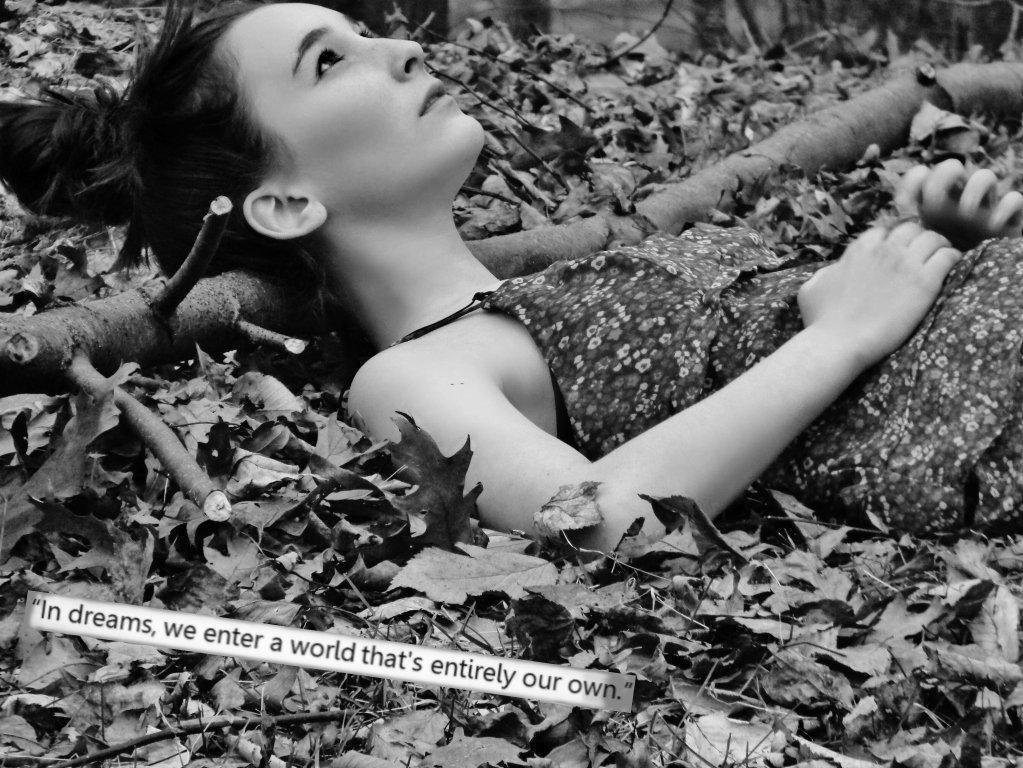What is the color scheme of the image? The image is black and white. What type of natural elements can be seen in the image? There are dry leaves, twigs, and a wooden log in the image. What is the position of the woman in the image? The woman is lying in the image. What is present at the bottom of the image? There is text at the bottom of the image. How would you describe the background of the image? The background is blurred. How many dinosaurs can be seen in the image? There are no dinosaurs present in the image. What type of cave is visible in the background of the image? There is no cave visible in the image; the background is blurred and does not show any specific location or structure. 